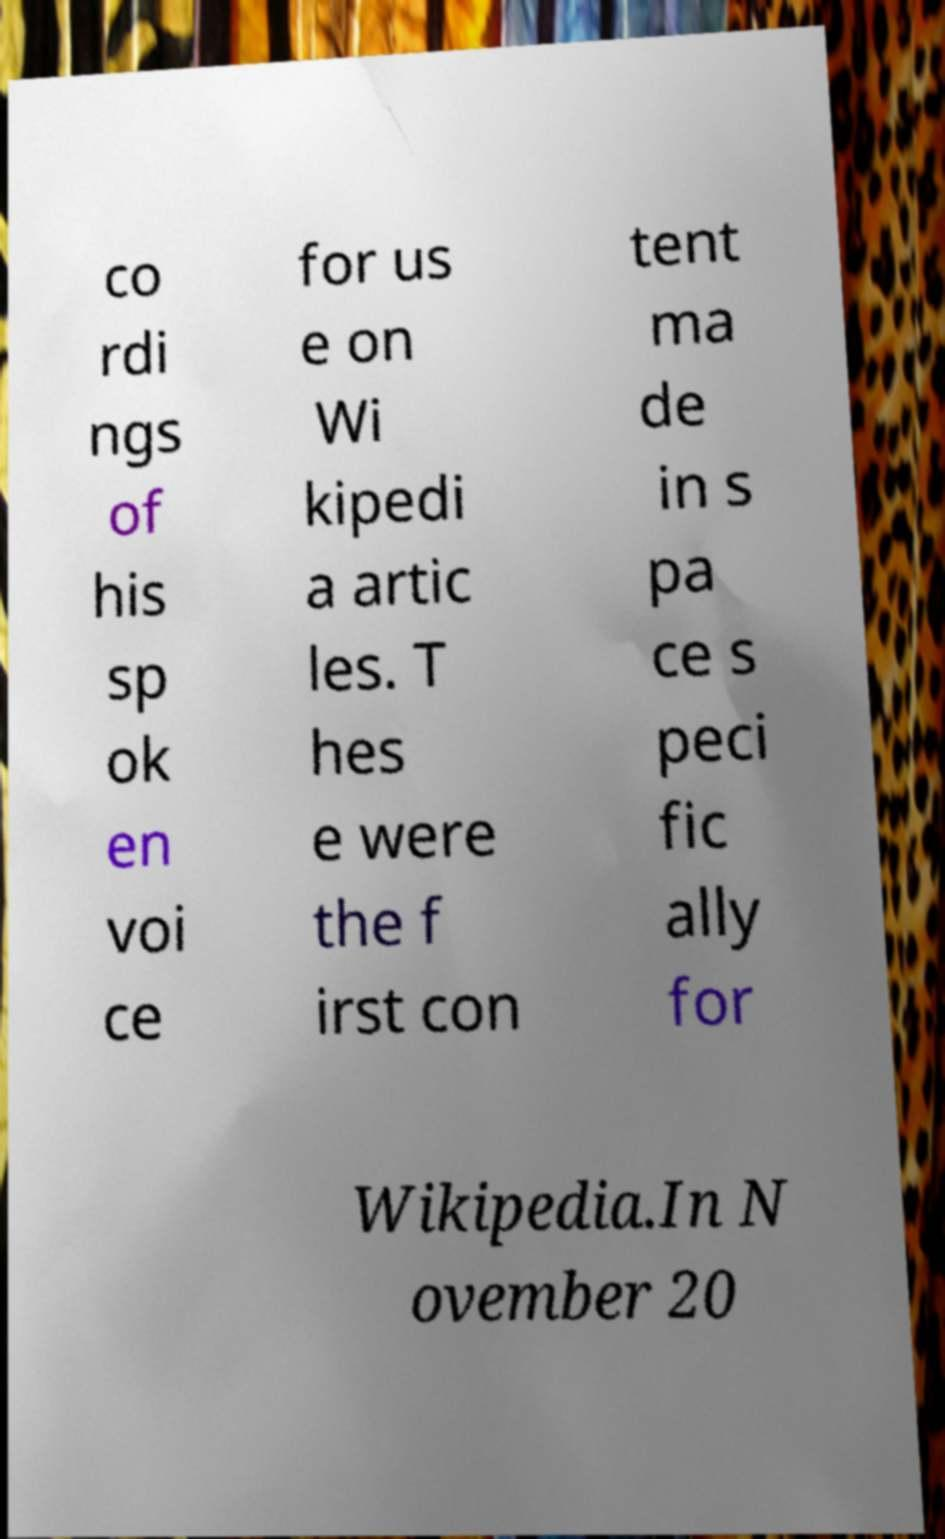There's text embedded in this image that I need extracted. Can you transcribe it verbatim? co rdi ngs of his sp ok en voi ce for us e on Wi kipedi a artic les. T hes e were the f irst con tent ma de in s pa ce s peci fic ally for Wikipedia.In N ovember 20 